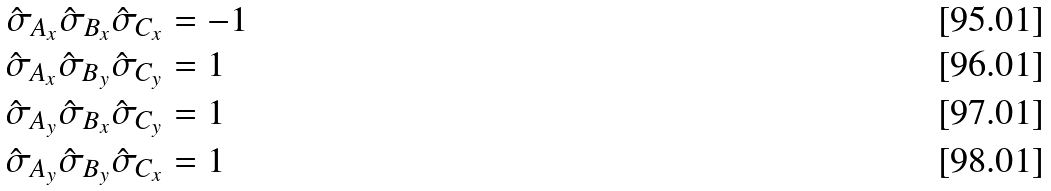Convert formula to latex. <formula><loc_0><loc_0><loc_500><loc_500>\hat { \sigma } _ { A _ { x } } \hat { \sigma } _ { B _ { x } } \hat { \sigma } _ { C _ { x } } & = - 1 \\ \hat { \sigma } _ { A _ { x } } \hat { \sigma } _ { B _ { y } } \hat { \sigma } _ { C _ { y } } & = 1 \\ \hat { \sigma } _ { A _ { y } } \hat { \sigma } _ { B _ { x } } \hat { \sigma } _ { C _ { y } } & = 1 \\ \hat { \sigma } _ { A _ { y } } \hat { \sigma } _ { B _ { y } } \hat { \sigma } _ { C _ { x } } & = 1</formula> 